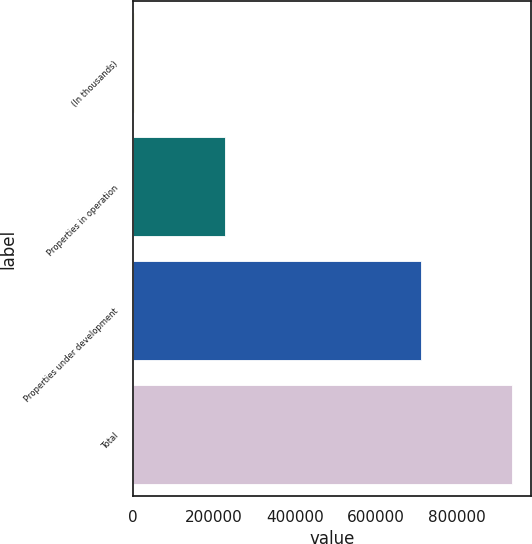Convert chart to OTSL. <chart><loc_0><loc_0><loc_500><loc_500><bar_chart><fcel>(In thousands)<fcel>Properties in operation<fcel>Properties under development<fcel>Total<nl><fcel>2015<fcel>226055<fcel>710312<fcel>936367<nl></chart> 